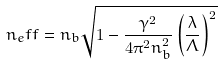Convert formula to latex. <formula><loc_0><loc_0><loc_500><loc_500>n _ { e } f f = n _ { b } \sqrt { 1 - \frac { \gamma ^ { 2 } } { 4 \pi ^ { 2 } n _ { b } ^ { 2 } } \left ( \frac { \lambda } { \Lambda } \right ) ^ { 2 } }</formula> 